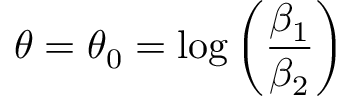Convert formula to latex. <formula><loc_0><loc_0><loc_500><loc_500>\theta = \theta _ { 0 } = \log { \left ( \frac { \beta _ { 1 } } { \beta _ { 2 } } \right ) }</formula> 